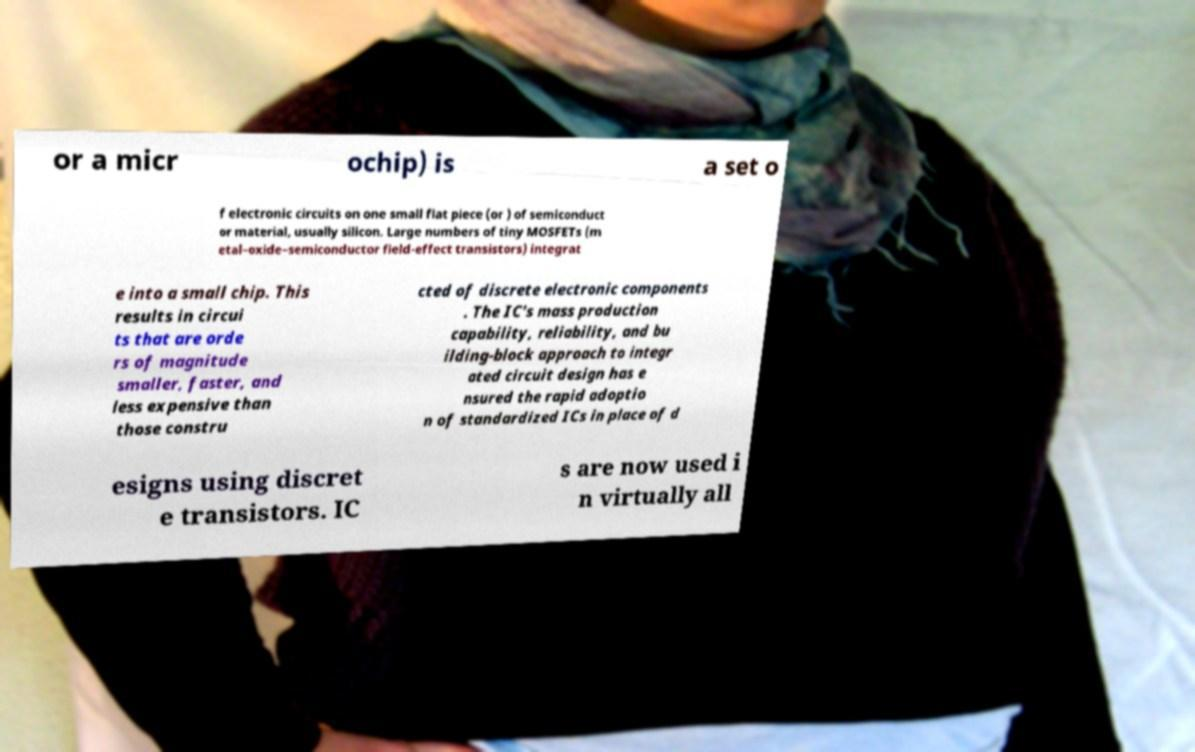I need the written content from this picture converted into text. Can you do that? or a micr ochip) is a set o f electronic circuits on one small flat piece (or ) of semiconduct or material, usually silicon. Large numbers of tiny MOSFETs (m etal–oxide–semiconductor field-effect transistors) integrat e into a small chip. This results in circui ts that are orde rs of magnitude smaller, faster, and less expensive than those constru cted of discrete electronic components . The IC's mass production capability, reliability, and bu ilding-block approach to integr ated circuit design has e nsured the rapid adoptio n of standardized ICs in place of d esigns using discret e transistors. IC s are now used i n virtually all 